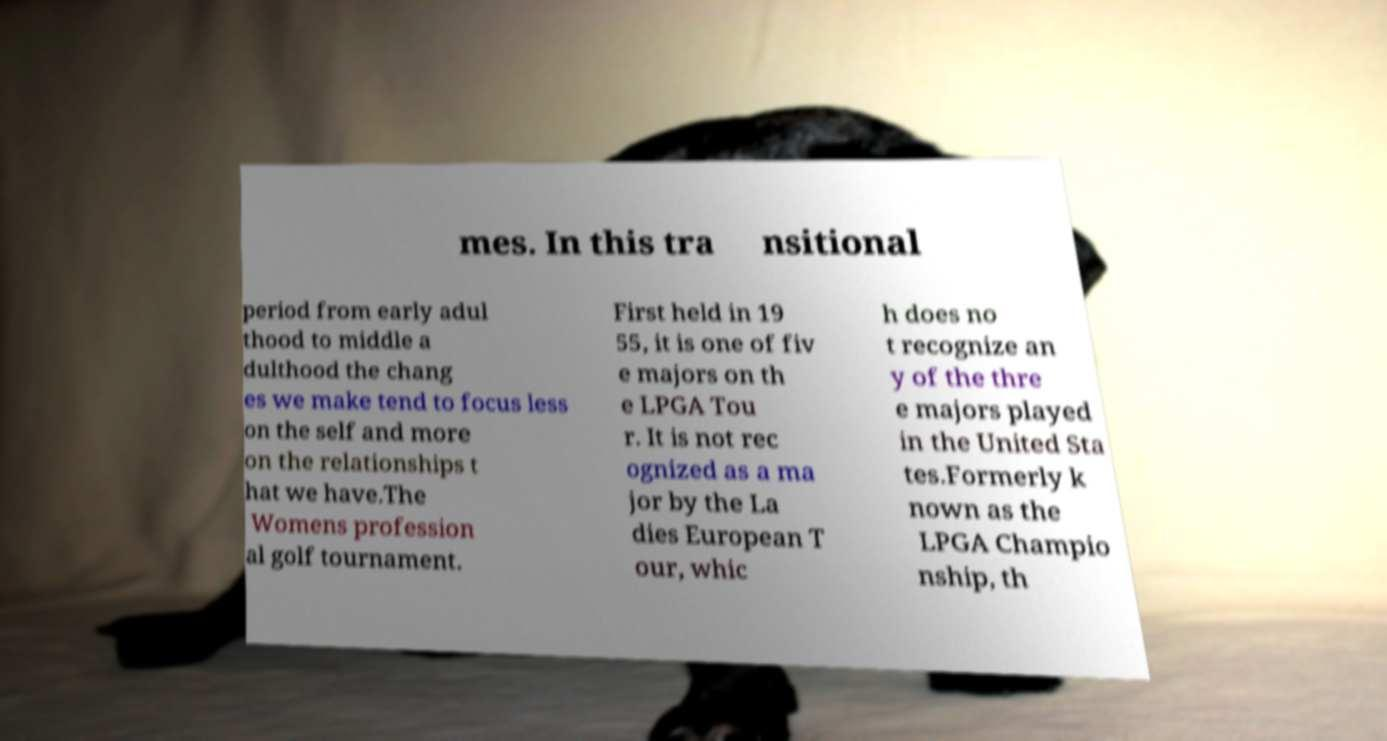Can you accurately transcribe the text from the provided image for me? mes. In this tra nsitional period from early adul thood to middle a dulthood the chang es we make tend to focus less on the self and more on the relationships t hat we have.The Womens profession al golf tournament. First held in 19 55, it is one of fiv e majors on th e LPGA Tou r. It is not rec ognized as a ma jor by the La dies European T our, whic h does no t recognize an y of the thre e majors played in the United Sta tes.Formerly k nown as the LPGA Champio nship, th 